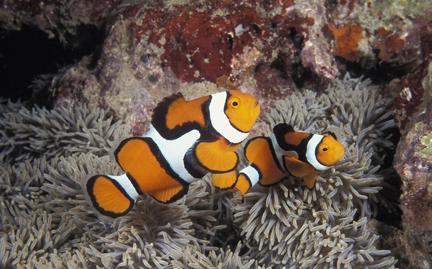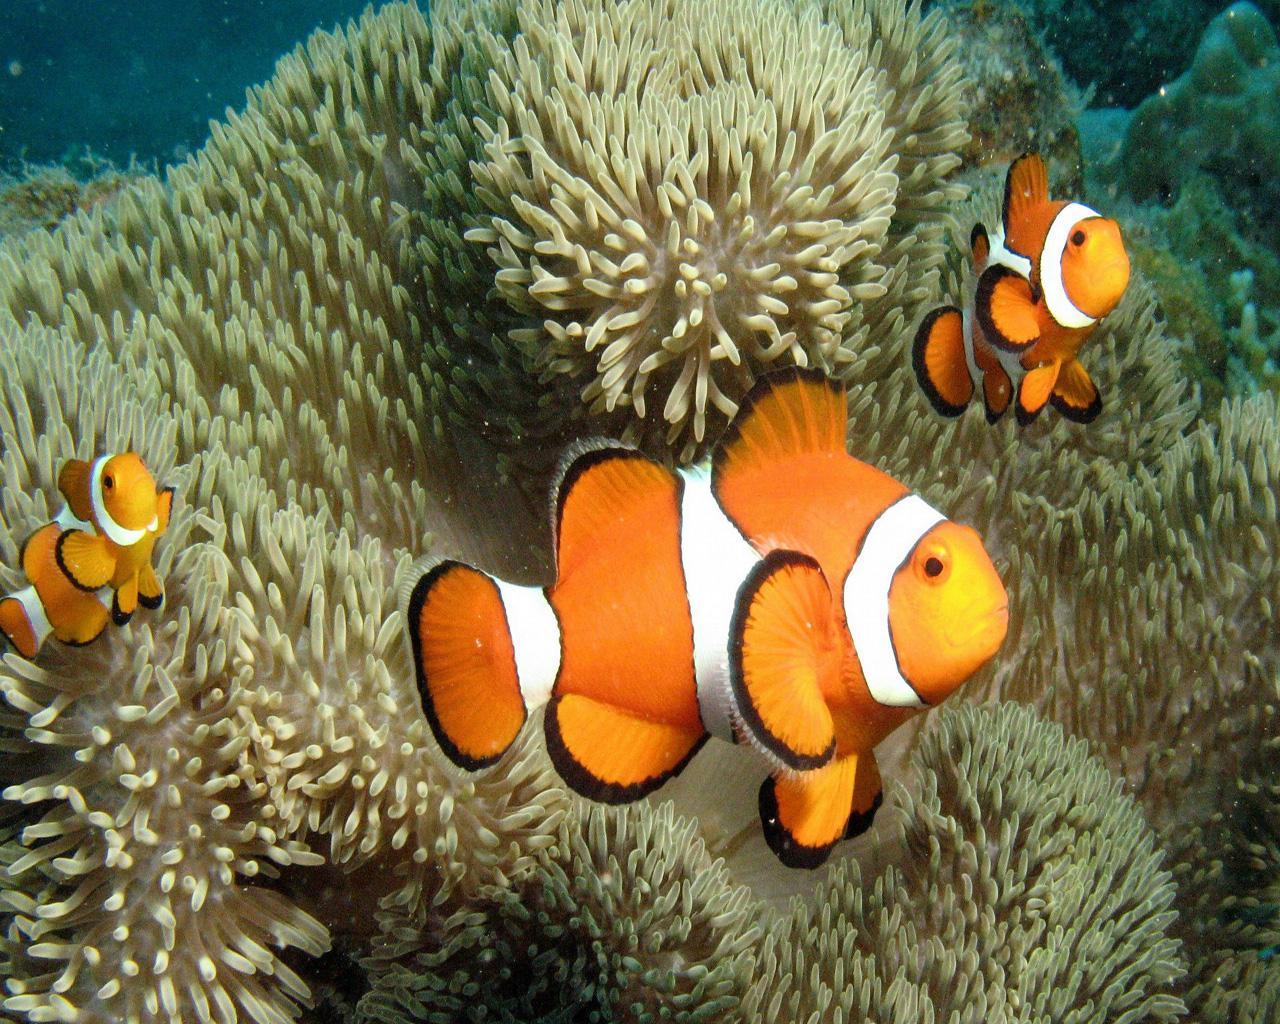The first image is the image on the left, the second image is the image on the right. Analyze the images presented: Is the assertion "There are 5 clownfish swimming." valid? Answer yes or no. Yes. 